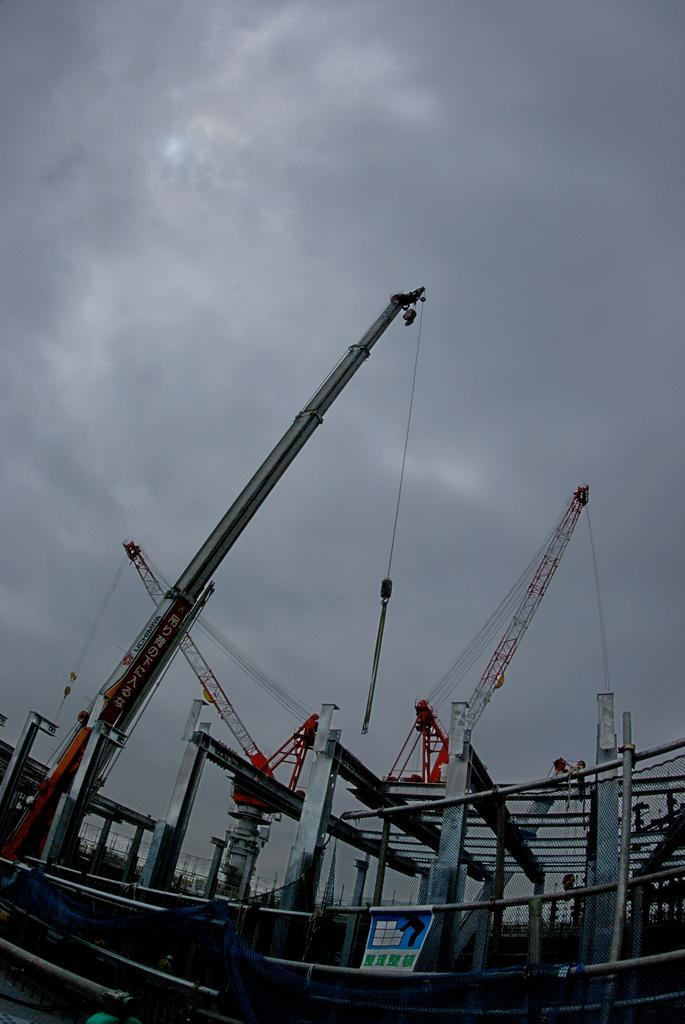What type of large machinery is present in the image? There are cranes in the image. What else can be seen in the image besides the cranes? There are rods in the image. Is there any signage or display on the rods? Yes, there is a poster on a rod in the image. What can be seen in the background of the image? The sky is visible in the background of the image. What type of finger can be seen holding the bottle in the image? There is no finger or bottle present in the image. 